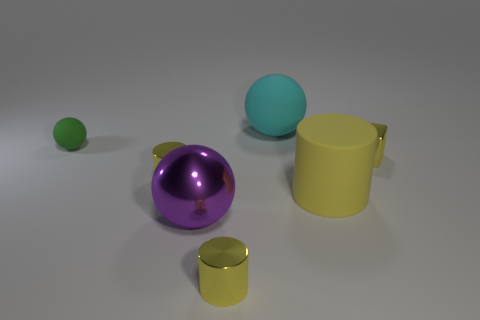Add 1 big purple objects. How many objects exist? 8 Subtract all blocks. How many objects are left? 6 Add 5 big yellow cylinders. How many big yellow cylinders exist? 6 Subtract 1 yellow cubes. How many objects are left? 6 Subtract all balls. Subtract all large cyan matte things. How many objects are left? 3 Add 2 big purple balls. How many big purple balls are left? 3 